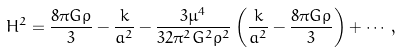<formula> <loc_0><loc_0><loc_500><loc_500>H ^ { 2 } = \frac { 8 \pi G \rho } { 3 } - \frac { k } { a ^ { 2 } } - \frac { 3 \mu ^ { 4 } } { 3 2 \pi ^ { 2 } G ^ { 2 } \rho ^ { 2 } } \left ( \frac { k } { a ^ { 2 } } - \frac { 8 \pi G \rho } { 3 } \right ) + \cdots ,</formula> 